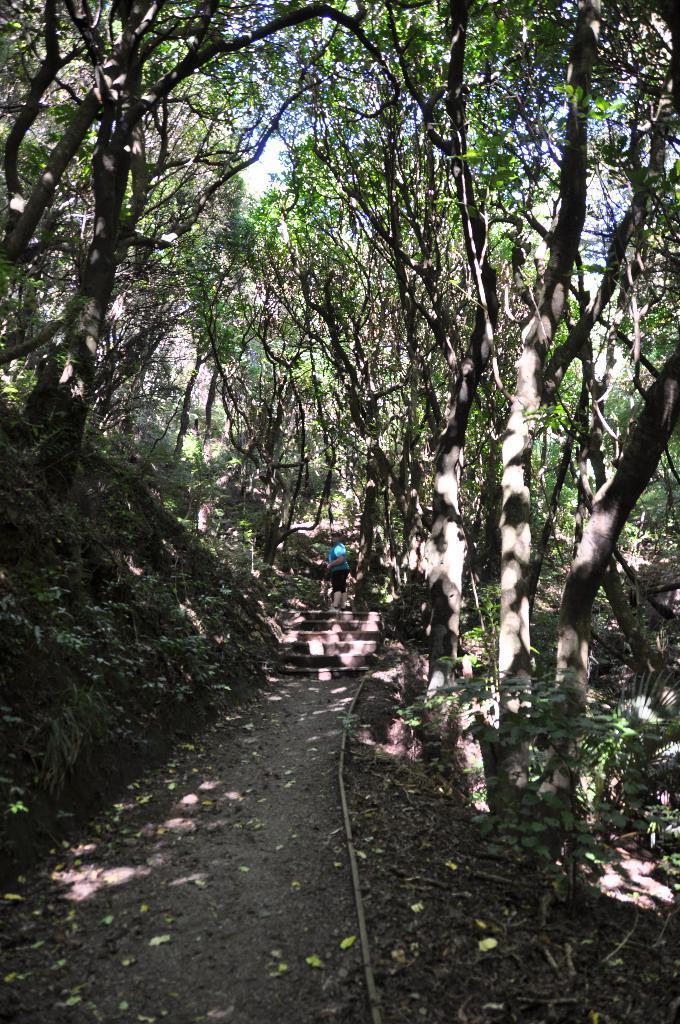Please provide a concise description of this image. In this picture we can see a person standing on the walkway. Behind the person, there are trees and the sky. 